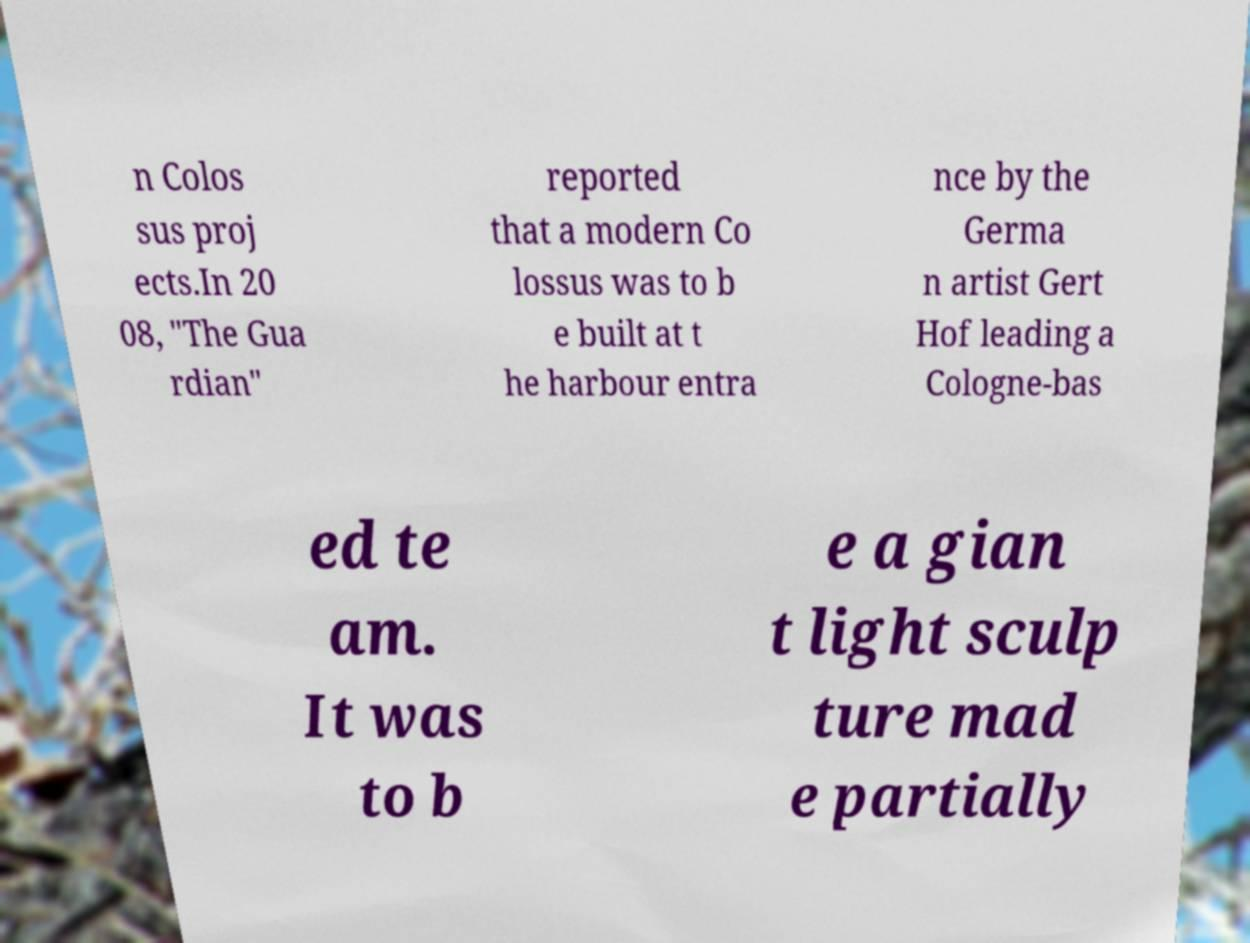Can you read and provide the text displayed in the image?This photo seems to have some interesting text. Can you extract and type it out for me? n Colos sus proj ects.In 20 08, "The Gua rdian" reported that a modern Co lossus was to b e built at t he harbour entra nce by the Germa n artist Gert Hof leading a Cologne-bas ed te am. It was to b e a gian t light sculp ture mad e partially 